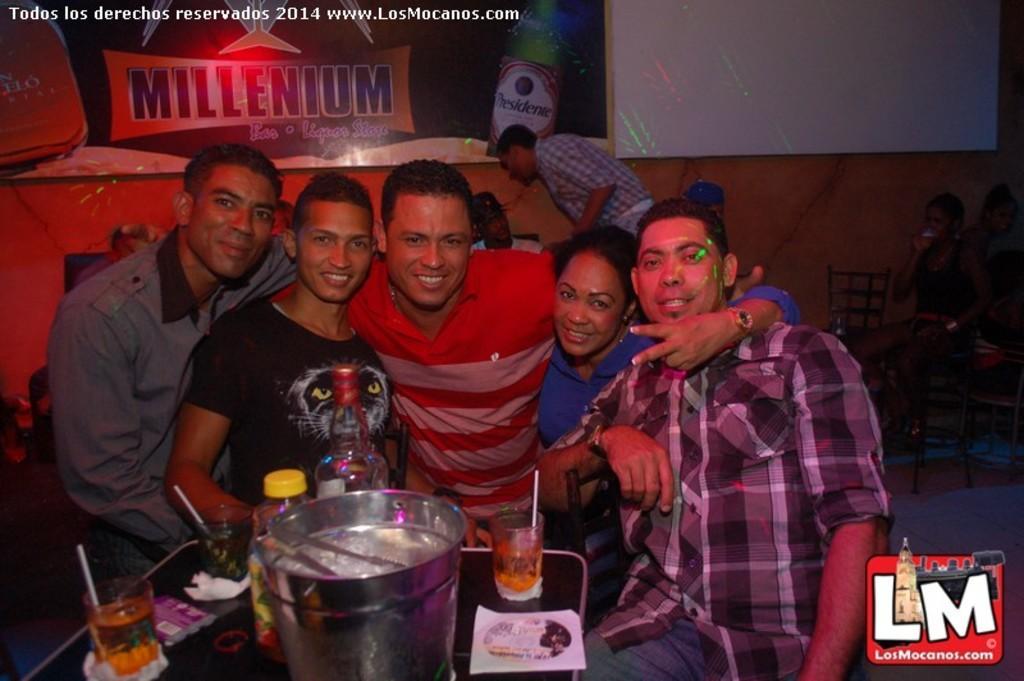Could you give a brief overview of what you see in this image? In this image I can see five persons posing. There are bottles, glasses, and some other objects on the table. There are few people in the background, there are chairs and there are boards attached to the wall. Also there are watermarks at the top and bottom of the image. 